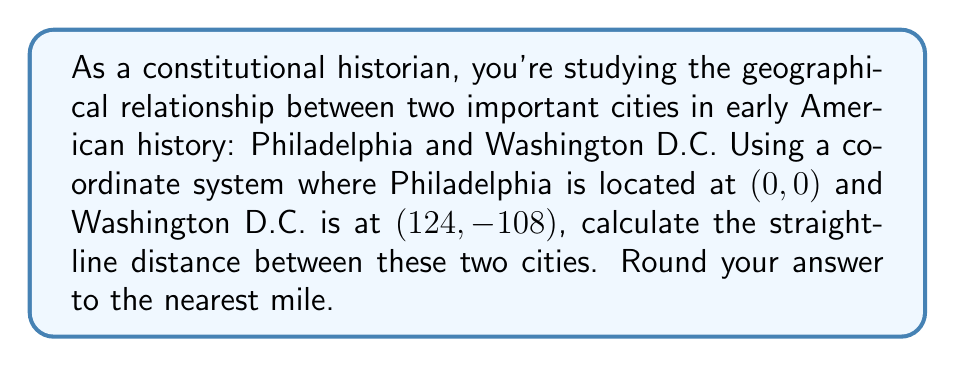Provide a solution to this math problem. To solve this problem, we can use the distance formula derived from the Pythagorean theorem. The distance formula for two points $(x_1, y_1)$ and $(x_2, y_2)$ is:

$$d = \sqrt{(x_2 - x_1)^2 + (y_2 - y_1)^2}$$

In our case:
- Philadelphia: $(x_1, y_1) = (0, 0)$
- Washington D.C.: $(x_2, y_2) = (124, -108)$

Let's substitute these values into the formula:

$$\begin{align*}
d &= \sqrt{(124 - 0)^2 + (-108 - 0)^2} \\
&= \sqrt{124^2 + (-108)^2} \\
&= \sqrt{15,376 + 11,664} \\
&= \sqrt{27,040} \\
&\approx 164.4379 \text{ miles}
\end{align*}$$

Rounding to the nearest mile, we get 164 miles.

This calculation provides a straight-line distance between the two cities, which is useful for understanding their relative positions in early American geography and the potential implications for communication and travel during the formation of the United States.
Answer: 164 miles 